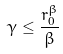<formula> <loc_0><loc_0><loc_500><loc_500>\gamma \leq \frac { r _ { 0 } ^ { \beta } } { \beta }</formula> 